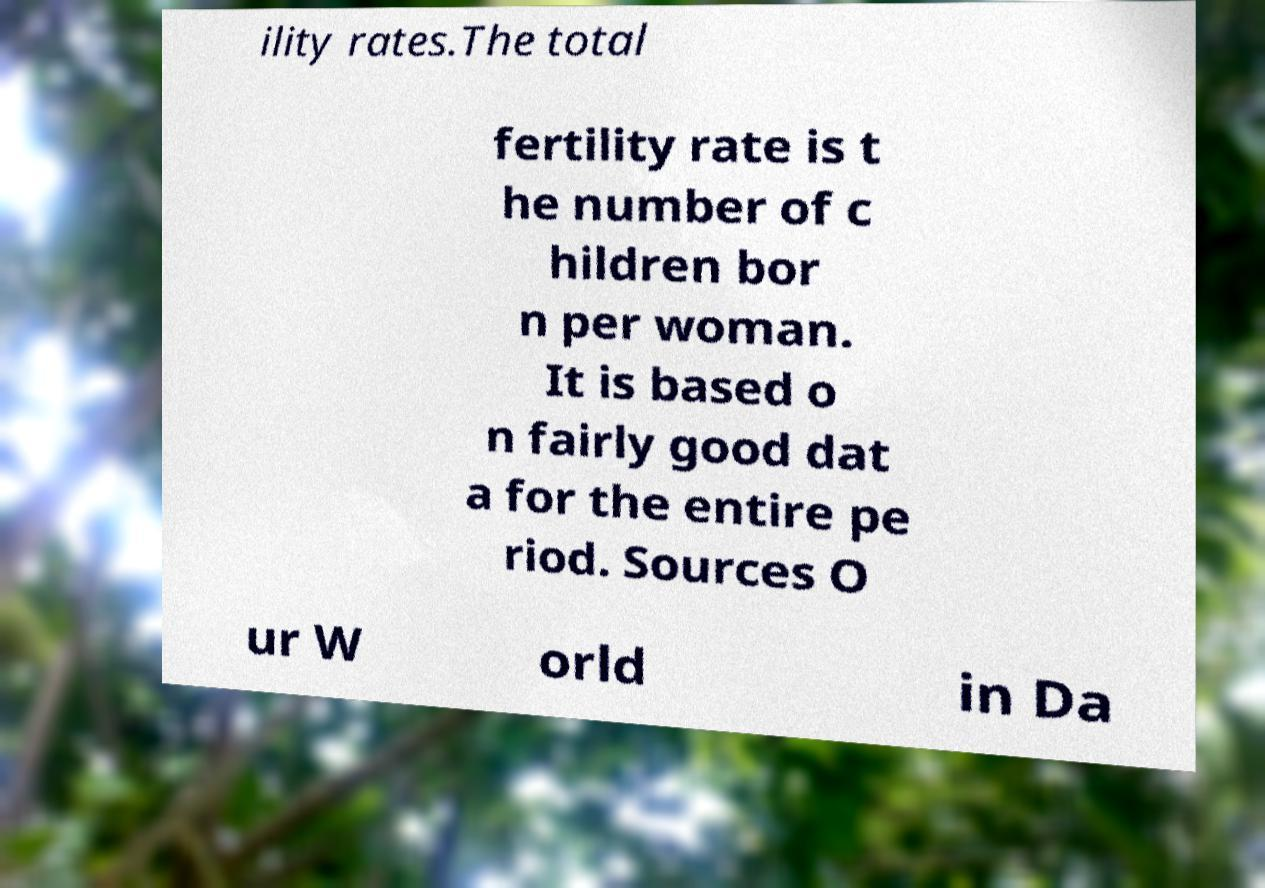Could you assist in decoding the text presented in this image and type it out clearly? ility rates.The total fertility rate is t he number of c hildren bor n per woman. It is based o n fairly good dat a for the entire pe riod. Sources O ur W orld in Da 